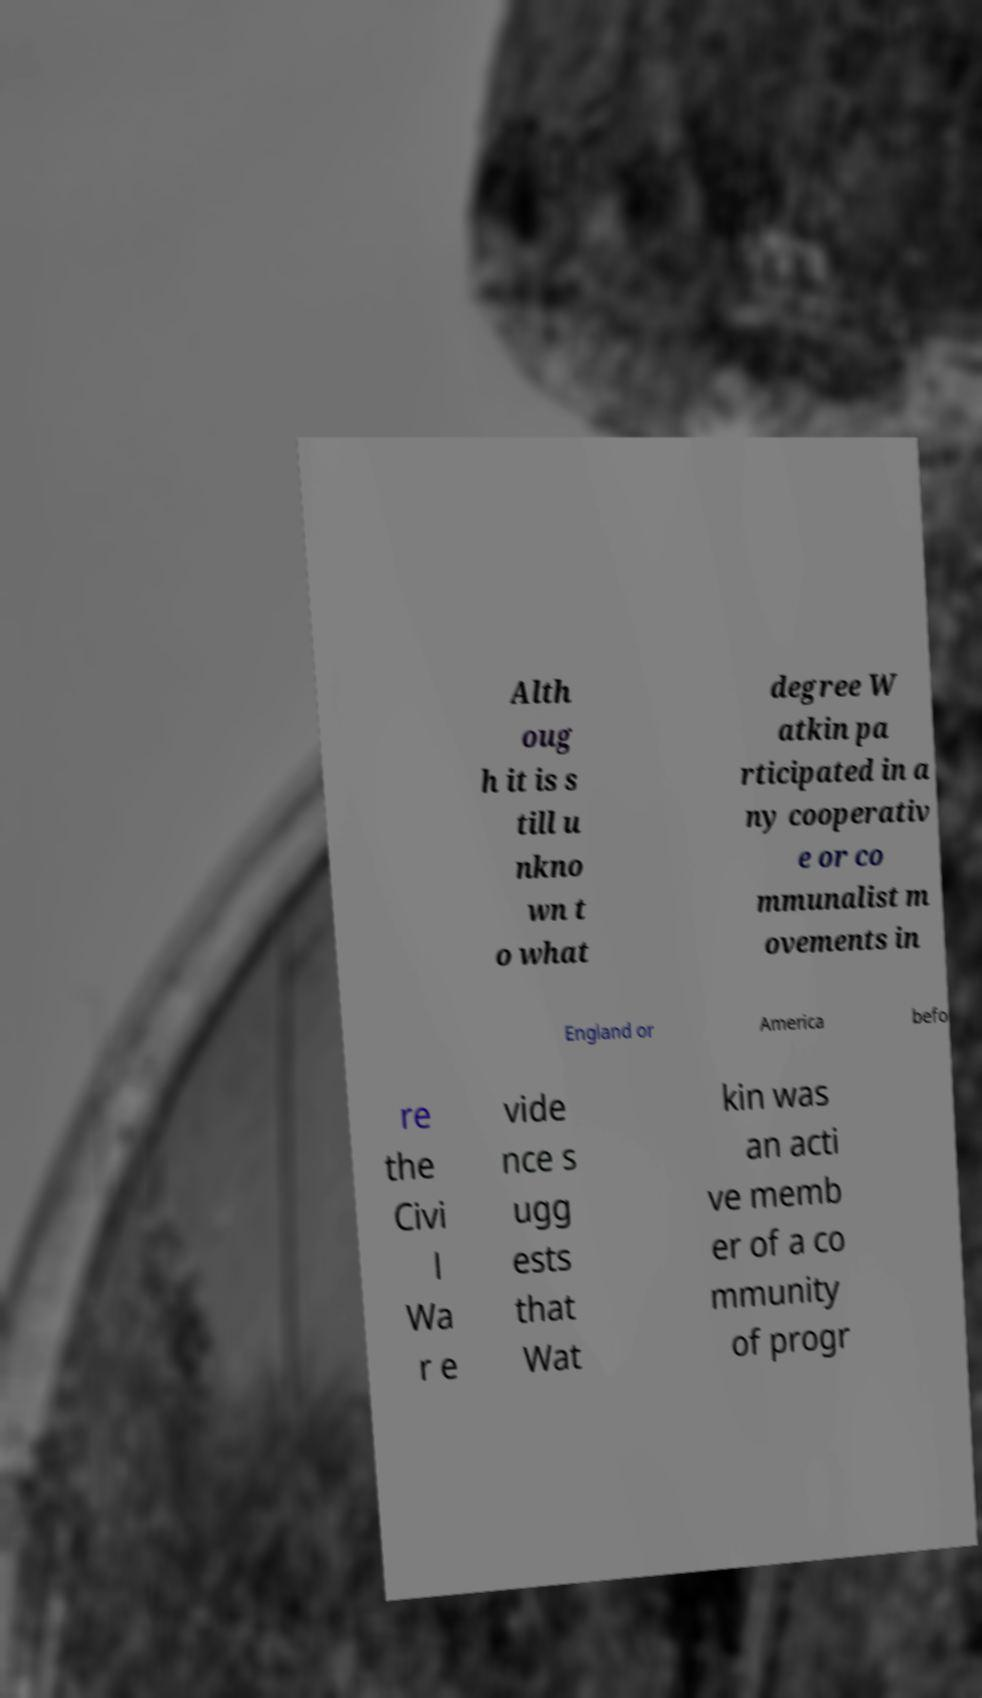Please identify and transcribe the text found in this image. Alth oug h it is s till u nkno wn t o what degree W atkin pa rticipated in a ny cooperativ e or co mmunalist m ovements in England or America befo re the Civi l Wa r e vide nce s ugg ests that Wat kin was an acti ve memb er of a co mmunity of progr 